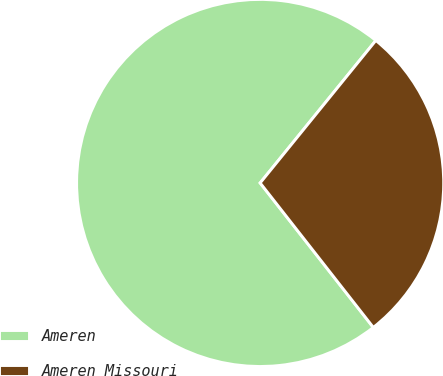Convert chart. <chart><loc_0><loc_0><loc_500><loc_500><pie_chart><fcel>Ameren<fcel>Ameren Missouri<nl><fcel>71.43%<fcel>28.57%<nl></chart> 